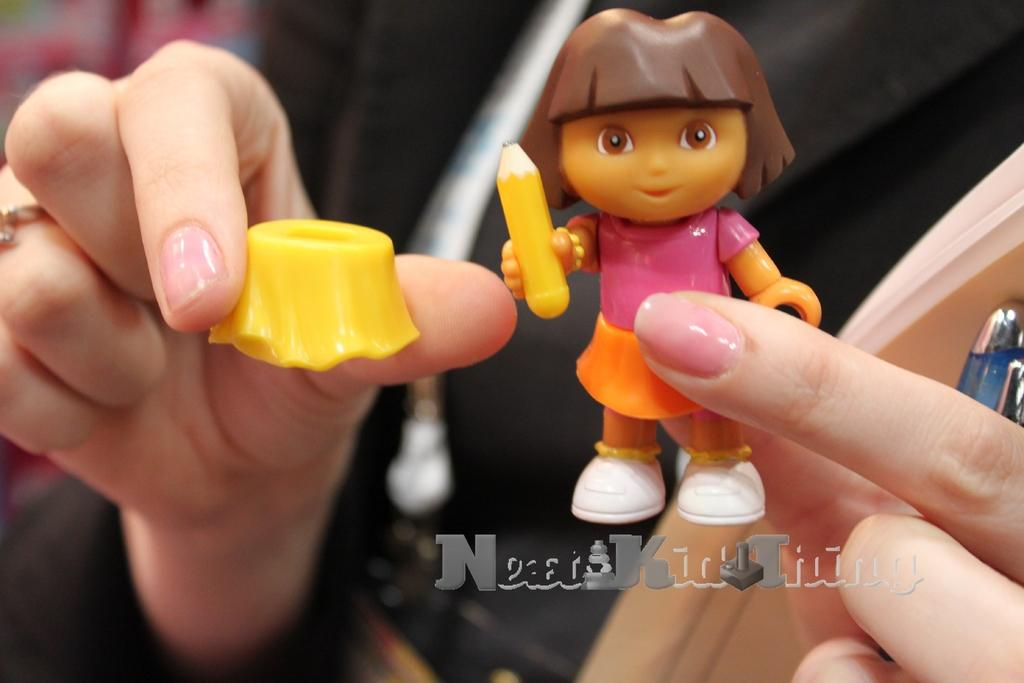Who or what is the main subject in the image? There is a person in the image. What is the person holding in their hands? The person is holding toys and a pen. Can you describe any text that is visible in the image? Yes, there is text at the bottom of the image. What type of fruit is the person using to write with in the image? There is no fruit present in the image; the person is using a pen to write. 